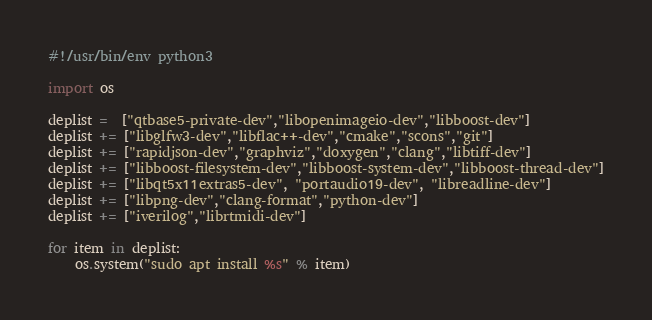<code> <loc_0><loc_0><loc_500><loc_500><_Python_>#!/usr/bin/env python3

import os

deplist =  ["qtbase5-private-dev","libopenimageio-dev","libboost-dev"]
deplist += ["libglfw3-dev","libflac++-dev","cmake","scons","git"]
deplist += ["rapidjson-dev","graphviz","doxygen","clang","libtiff-dev"]
deplist += ["libboost-filesystem-dev","libboost-system-dev","libboost-thread-dev"]
deplist += ["libqt5x11extras5-dev", "portaudio19-dev", "libreadline-dev"]
deplist += ["libpng-dev","clang-format","python-dev"]
deplist += ["iverilog","librtmidi-dev"]

for item in deplist:
    os.system("sudo apt install %s" % item)
</code> 